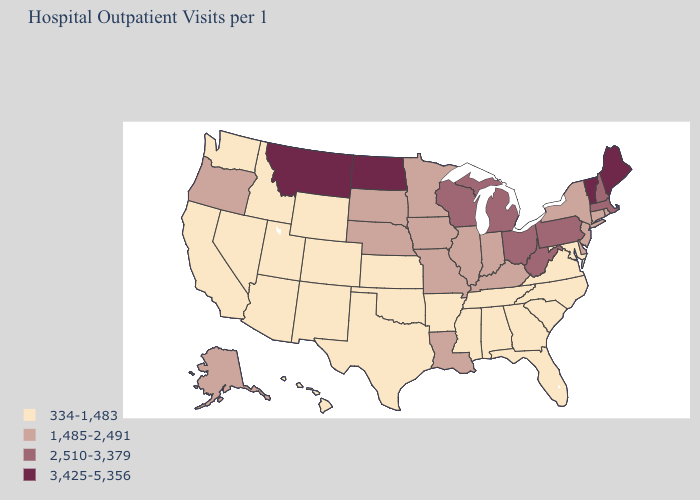Which states have the highest value in the USA?
Be succinct. Maine, Montana, North Dakota, Vermont. Does Wisconsin have the same value as Mississippi?
Answer briefly. No. What is the value of Maryland?
Keep it brief. 334-1,483. Among the states that border Texas , does Louisiana have the lowest value?
Keep it brief. No. What is the lowest value in the USA?
Write a very short answer. 334-1,483. Does the map have missing data?
Write a very short answer. No. Does Kentucky have the highest value in the South?
Give a very brief answer. No. Is the legend a continuous bar?
Short answer required. No. Name the states that have a value in the range 2,510-3,379?
Give a very brief answer. Massachusetts, Michigan, New Hampshire, Ohio, Pennsylvania, West Virginia, Wisconsin. Name the states that have a value in the range 2,510-3,379?
Quick response, please. Massachusetts, Michigan, New Hampshire, Ohio, Pennsylvania, West Virginia, Wisconsin. What is the value of Connecticut?
Short answer required. 1,485-2,491. What is the value of California?
Quick response, please. 334-1,483. Name the states that have a value in the range 1,485-2,491?
Give a very brief answer. Alaska, Connecticut, Delaware, Illinois, Indiana, Iowa, Kentucky, Louisiana, Minnesota, Missouri, Nebraska, New Jersey, New York, Oregon, Rhode Island, South Dakota. Does West Virginia have a higher value than Ohio?
Keep it brief. No. 